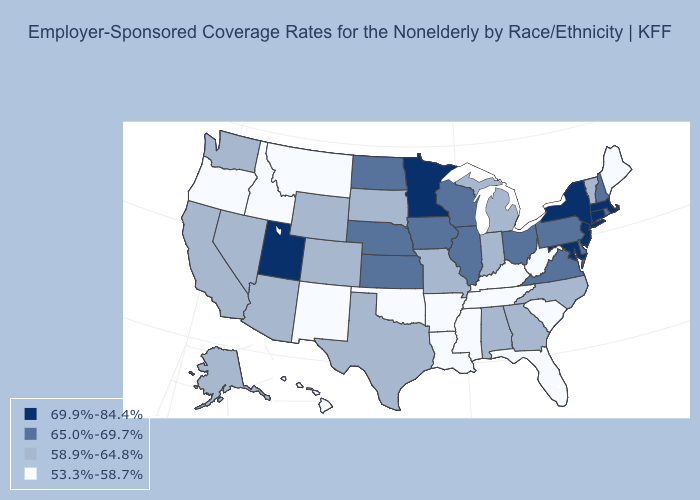Name the states that have a value in the range 53.3%-58.7%?
Answer briefly. Arkansas, Florida, Hawaii, Idaho, Kentucky, Louisiana, Maine, Mississippi, Montana, New Mexico, Oklahoma, Oregon, South Carolina, Tennessee, West Virginia. Which states have the highest value in the USA?
Be succinct. Connecticut, Maryland, Massachusetts, Minnesota, New Jersey, New York, Utah. What is the value of Arizona?
Be succinct. 58.9%-64.8%. Does Connecticut have the highest value in the USA?
Short answer required. Yes. What is the lowest value in the Northeast?
Quick response, please. 53.3%-58.7%. What is the value of Michigan?
Concise answer only. 58.9%-64.8%. What is the lowest value in the Northeast?
Quick response, please. 53.3%-58.7%. What is the value of Kentucky?
Write a very short answer. 53.3%-58.7%. Does Vermont have the same value as Oregon?
Short answer required. No. Name the states that have a value in the range 65.0%-69.7%?
Concise answer only. Delaware, Illinois, Iowa, Kansas, Nebraska, New Hampshire, North Dakota, Ohio, Pennsylvania, Rhode Island, Virginia, Wisconsin. Which states have the highest value in the USA?
Short answer required. Connecticut, Maryland, Massachusetts, Minnesota, New Jersey, New York, Utah. Which states have the lowest value in the USA?
Be succinct. Arkansas, Florida, Hawaii, Idaho, Kentucky, Louisiana, Maine, Mississippi, Montana, New Mexico, Oklahoma, Oregon, South Carolina, Tennessee, West Virginia. Name the states that have a value in the range 65.0%-69.7%?
Give a very brief answer. Delaware, Illinois, Iowa, Kansas, Nebraska, New Hampshire, North Dakota, Ohio, Pennsylvania, Rhode Island, Virginia, Wisconsin. What is the lowest value in states that border Nebraska?
Answer briefly. 58.9%-64.8%. Name the states that have a value in the range 53.3%-58.7%?
Concise answer only. Arkansas, Florida, Hawaii, Idaho, Kentucky, Louisiana, Maine, Mississippi, Montana, New Mexico, Oklahoma, Oregon, South Carolina, Tennessee, West Virginia. 